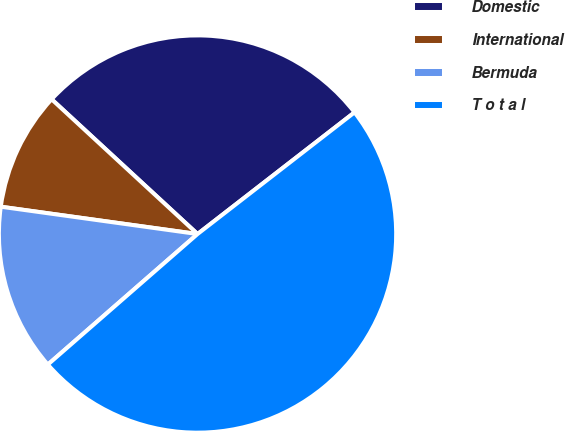Convert chart. <chart><loc_0><loc_0><loc_500><loc_500><pie_chart><fcel>Domestic<fcel>International<fcel>Bermuda<fcel>T o t a l<nl><fcel>27.64%<fcel>9.67%<fcel>13.61%<fcel>49.08%<nl></chart> 